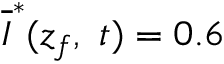<formula> <loc_0><loc_0><loc_500><loc_500>\overline { I } ^ { * } ( z _ { f } , \ t ) = 0 . 6</formula> 